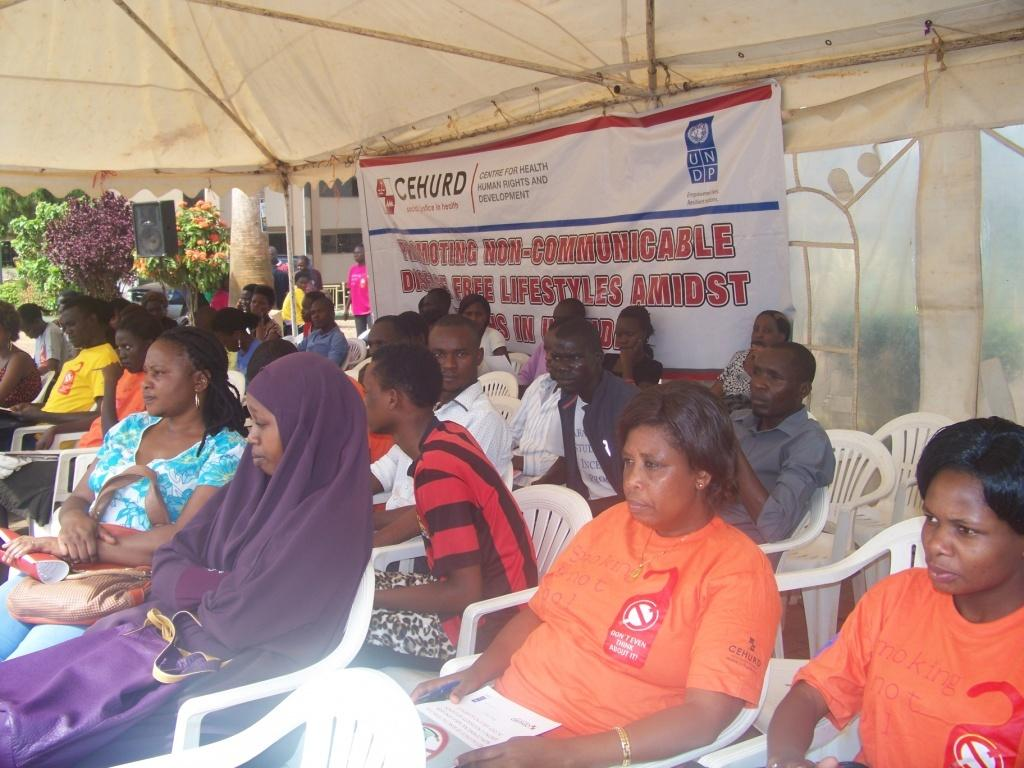What is the main subject of the image? The main subject of the image is a group of people. What are some of the people in the image doing? Some people are sitting on chairs, while others are standing. What can be seen behind the people in the image? There is a banner behind the people. What is visible in the background of the image? Trees are visible in the background. What type of sweater is the person in the image wearing? There is no person wearing a sweater in the image. Can you tell me how many buildings are visible in the image? There are no buildings visible in the image; only trees are present in the background. 